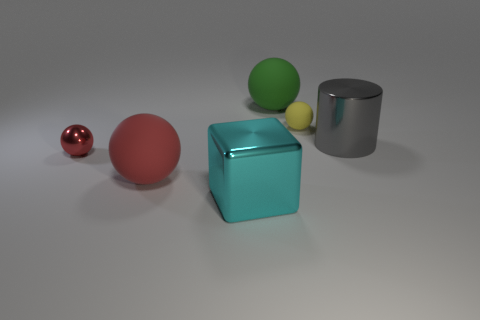There is a red object that is on the right side of the red metal ball; is it the same shape as the tiny thing on the right side of the large green ball?
Offer a terse response. Yes. There is a shiny thing that is both on the right side of the small shiny ball and left of the gray metallic cylinder; what is its color?
Your answer should be compact. Cyan. There is a large cube; is its color the same as the large metallic object right of the large green matte object?
Your answer should be very brief. No. What size is the thing that is in front of the yellow ball and to the right of the green sphere?
Give a very brief answer. Large. What number of other objects are there of the same color as the small shiny ball?
Offer a very short reply. 1. What size is the matte ball that is left of the big metallic object left of the big sphere behind the gray metallic object?
Ensure brevity in your answer.  Large. There is a cyan cube; are there any shiny things on the left side of it?
Make the answer very short. Yes. There is a green ball; is it the same size as the matte sphere in front of the cylinder?
Offer a terse response. Yes. How many other things are the same material as the big cyan object?
Your answer should be compact. 2. What shape is the rubber thing that is in front of the green sphere and behind the small red shiny ball?
Offer a very short reply. Sphere. 